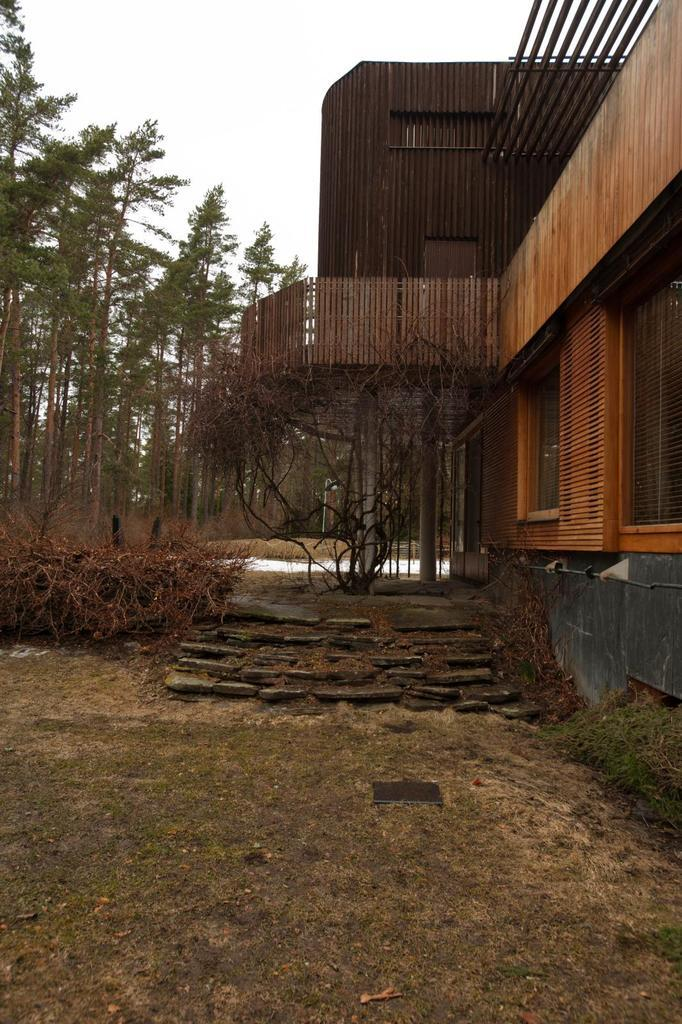What structure is located on the left side of the image? There is a house on the left side of the image. What can be seen in the center of the image? There are stairs in the center of the image. What type of vegetation is near the stairs? There are plants near the stairs. What type of ground is visible at the bottom of the image? There is grass at the bottom of the image. What is visible in the background of the image? There are trees in the background of the image. How much tax is being paid for the house in the image? There is no information about taxes in the image, as it only shows a house, stairs, plants, grass, and trees. What type of whip is being used by the person standing near the stairs? There is no person or whip present in the image. 